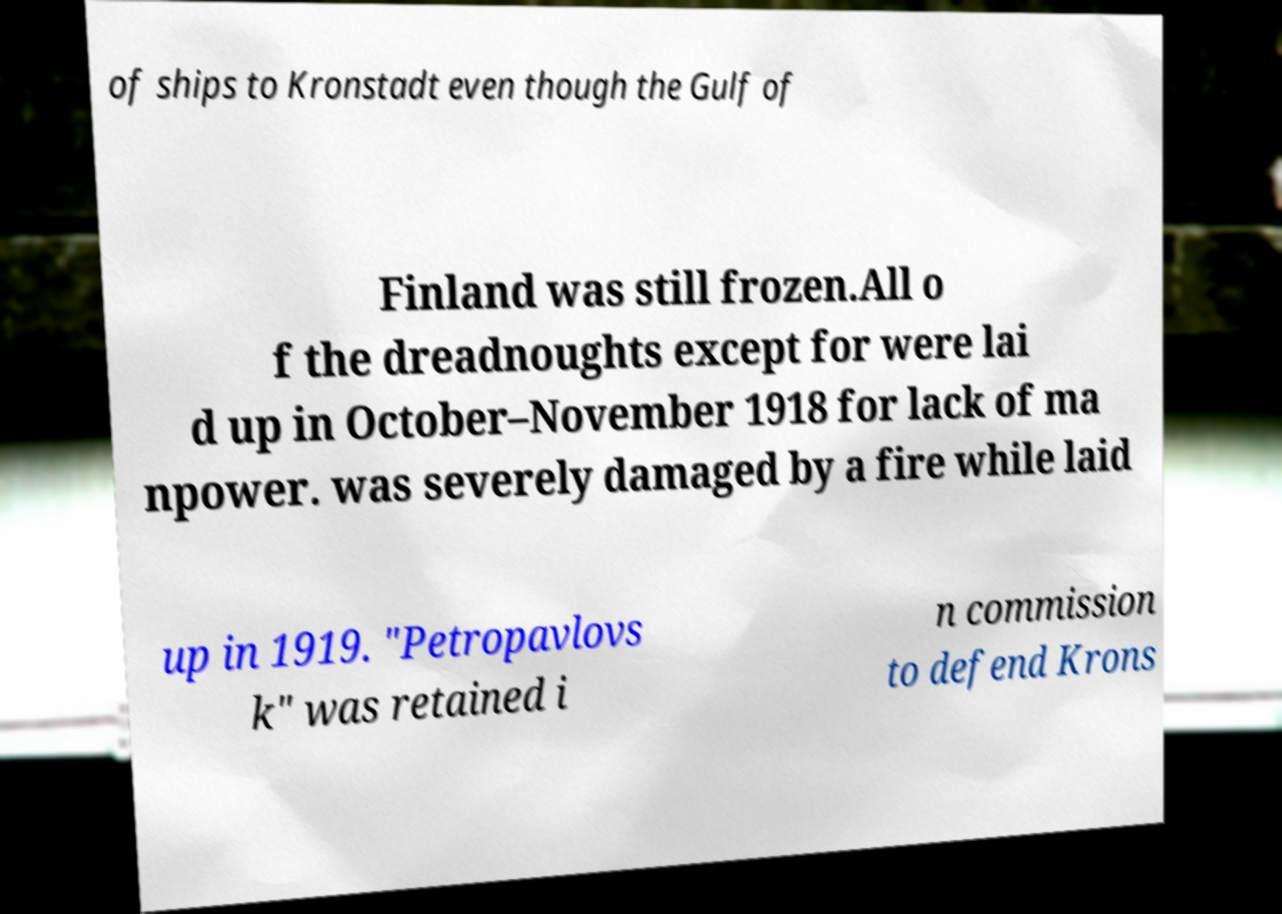There's text embedded in this image that I need extracted. Can you transcribe it verbatim? of ships to Kronstadt even though the Gulf of Finland was still frozen.All o f the dreadnoughts except for were lai d up in October–November 1918 for lack of ma npower. was severely damaged by a fire while laid up in 1919. "Petropavlovs k" was retained i n commission to defend Krons 